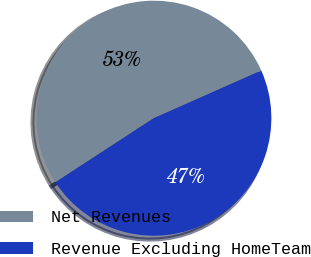Convert chart to OTSL. <chart><loc_0><loc_0><loc_500><loc_500><pie_chart><fcel>Net Revenues<fcel>Revenue Excluding HomeTeam<nl><fcel>52.55%<fcel>47.45%<nl></chart> 